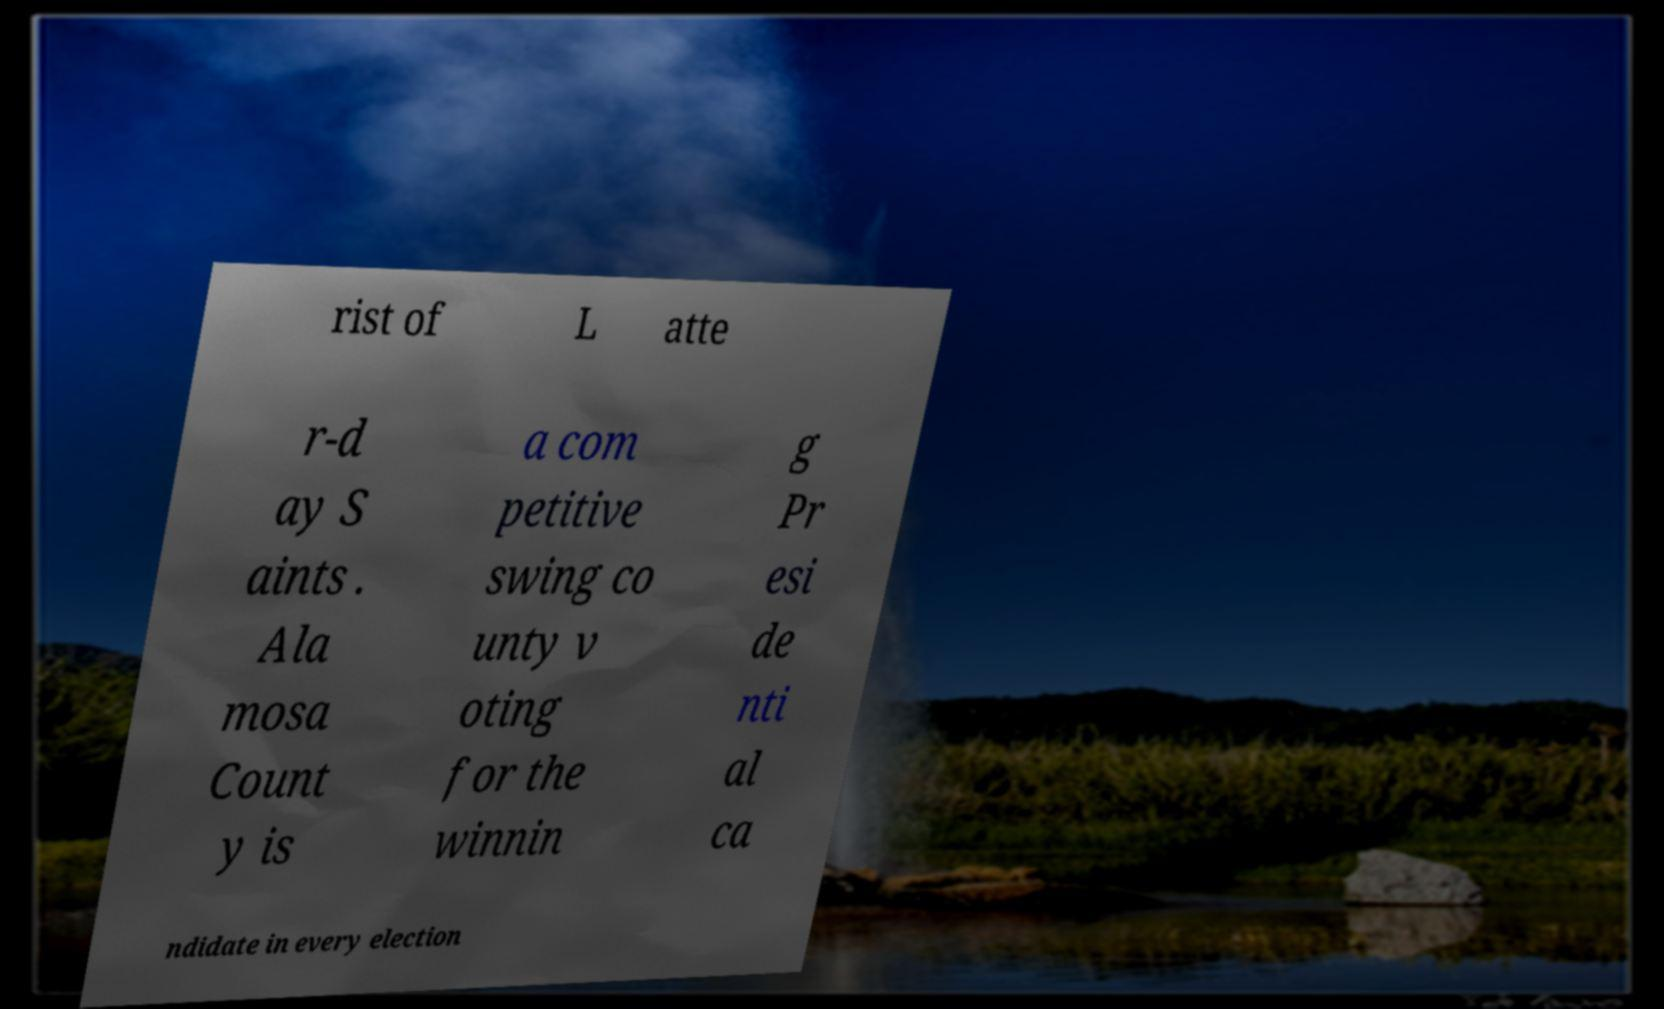Please read and relay the text visible in this image. What does it say? rist of L atte r-d ay S aints . Ala mosa Count y is a com petitive swing co unty v oting for the winnin g Pr esi de nti al ca ndidate in every election 